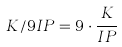Convert formula to latex. <formula><loc_0><loc_0><loc_500><loc_500>K / 9 I P = 9 \cdot \frac { K } { I P }</formula> 